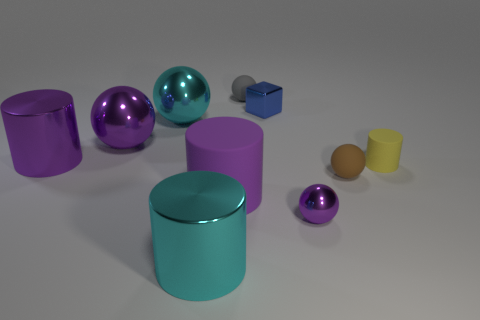Subtract all gray spheres. How many spheres are left? 4 Subtract all big purple spheres. How many spheres are left? 4 Subtract all gray balls. Subtract all cyan blocks. How many balls are left? 4 Subtract all cylinders. How many objects are left? 6 Subtract 0 red spheres. How many objects are left? 10 Subtract all small green metallic things. Subtract all tiny yellow things. How many objects are left? 9 Add 5 gray objects. How many gray objects are left? 6 Add 2 blue metallic blocks. How many blue metallic blocks exist? 3 